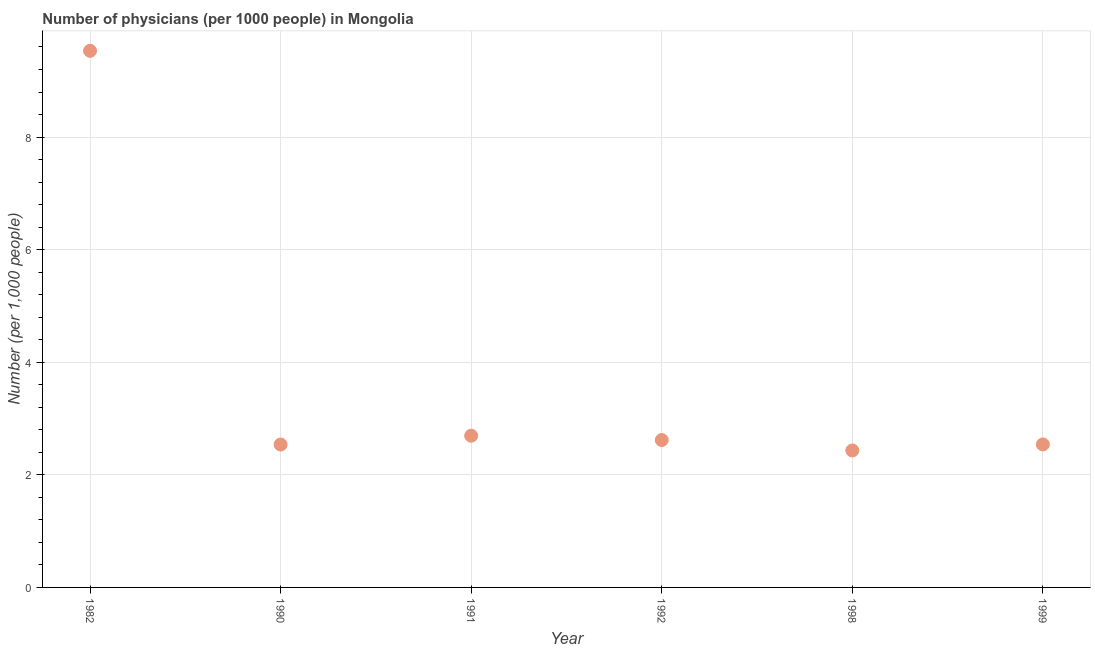What is the number of physicians in 1991?
Your answer should be very brief. 2.69. Across all years, what is the maximum number of physicians?
Your answer should be very brief. 9.53. Across all years, what is the minimum number of physicians?
Provide a short and direct response. 2.43. In which year was the number of physicians maximum?
Your answer should be very brief. 1982. In which year was the number of physicians minimum?
Offer a very short reply. 1998. What is the sum of the number of physicians?
Ensure brevity in your answer.  22.36. What is the difference between the number of physicians in 1990 and 1991?
Provide a short and direct response. -0.16. What is the average number of physicians per year?
Provide a short and direct response. 3.73. What is the median number of physicians?
Give a very brief answer. 2.58. In how many years, is the number of physicians greater than 2.4 ?
Provide a succinct answer. 6. Do a majority of the years between 1992 and 1998 (inclusive) have number of physicians greater than 3.2 ?
Your response must be concise. No. What is the ratio of the number of physicians in 1982 to that in 1992?
Provide a short and direct response. 3.64. What is the difference between the highest and the second highest number of physicians?
Your response must be concise. 6.84. What is the difference between the highest and the lowest number of physicians?
Offer a very short reply. 7.1. In how many years, is the number of physicians greater than the average number of physicians taken over all years?
Make the answer very short. 1. How many dotlines are there?
Make the answer very short. 1. What is the difference between two consecutive major ticks on the Y-axis?
Your answer should be compact. 2. Does the graph contain any zero values?
Provide a short and direct response. No. Does the graph contain grids?
Offer a terse response. Yes. What is the title of the graph?
Ensure brevity in your answer.  Number of physicians (per 1000 people) in Mongolia. What is the label or title of the Y-axis?
Provide a short and direct response. Number (per 1,0 people). What is the Number (per 1,000 people) in 1982?
Your answer should be very brief. 9.53. What is the Number (per 1,000 people) in 1990?
Give a very brief answer. 2.54. What is the Number (per 1,000 people) in 1991?
Your response must be concise. 2.69. What is the Number (per 1,000 people) in 1992?
Your answer should be compact. 2.62. What is the Number (per 1,000 people) in 1998?
Your answer should be very brief. 2.43. What is the Number (per 1,000 people) in 1999?
Offer a terse response. 2.54. What is the difference between the Number (per 1,000 people) in 1982 and 1990?
Your answer should be compact. 6.99. What is the difference between the Number (per 1,000 people) in 1982 and 1991?
Offer a terse response. 6.84. What is the difference between the Number (per 1,000 people) in 1982 and 1992?
Ensure brevity in your answer.  6.91. What is the difference between the Number (per 1,000 people) in 1982 and 1998?
Your answer should be compact. 7.1. What is the difference between the Number (per 1,000 people) in 1982 and 1999?
Provide a succinct answer. 6.99. What is the difference between the Number (per 1,000 people) in 1990 and 1991?
Offer a very short reply. -0.16. What is the difference between the Number (per 1,000 people) in 1990 and 1992?
Your answer should be very brief. -0.08. What is the difference between the Number (per 1,000 people) in 1990 and 1998?
Ensure brevity in your answer.  0.11. What is the difference between the Number (per 1,000 people) in 1990 and 1999?
Make the answer very short. -0. What is the difference between the Number (per 1,000 people) in 1991 and 1992?
Give a very brief answer. 0.08. What is the difference between the Number (per 1,000 people) in 1991 and 1998?
Keep it short and to the point. 0.26. What is the difference between the Number (per 1,000 people) in 1991 and 1999?
Your answer should be compact. 0.15. What is the difference between the Number (per 1,000 people) in 1992 and 1998?
Offer a terse response. 0.18. What is the difference between the Number (per 1,000 people) in 1992 and 1999?
Provide a short and direct response. 0.08. What is the difference between the Number (per 1,000 people) in 1998 and 1999?
Make the answer very short. -0.11. What is the ratio of the Number (per 1,000 people) in 1982 to that in 1990?
Offer a terse response. 3.75. What is the ratio of the Number (per 1,000 people) in 1982 to that in 1991?
Offer a very short reply. 3.54. What is the ratio of the Number (per 1,000 people) in 1982 to that in 1992?
Give a very brief answer. 3.64. What is the ratio of the Number (per 1,000 people) in 1982 to that in 1998?
Provide a short and direct response. 3.92. What is the ratio of the Number (per 1,000 people) in 1982 to that in 1999?
Your answer should be very brief. 3.75. What is the ratio of the Number (per 1,000 people) in 1990 to that in 1991?
Provide a short and direct response. 0.94. What is the ratio of the Number (per 1,000 people) in 1990 to that in 1992?
Your answer should be compact. 0.97. What is the ratio of the Number (per 1,000 people) in 1990 to that in 1998?
Ensure brevity in your answer.  1.04. What is the ratio of the Number (per 1,000 people) in 1990 to that in 1999?
Provide a succinct answer. 1. What is the ratio of the Number (per 1,000 people) in 1991 to that in 1998?
Provide a succinct answer. 1.11. What is the ratio of the Number (per 1,000 people) in 1991 to that in 1999?
Offer a very short reply. 1.06. What is the ratio of the Number (per 1,000 people) in 1992 to that in 1998?
Your answer should be compact. 1.08. What is the ratio of the Number (per 1,000 people) in 1992 to that in 1999?
Your answer should be compact. 1.03. What is the ratio of the Number (per 1,000 people) in 1998 to that in 1999?
Provide a succinct answer. 0.96. 